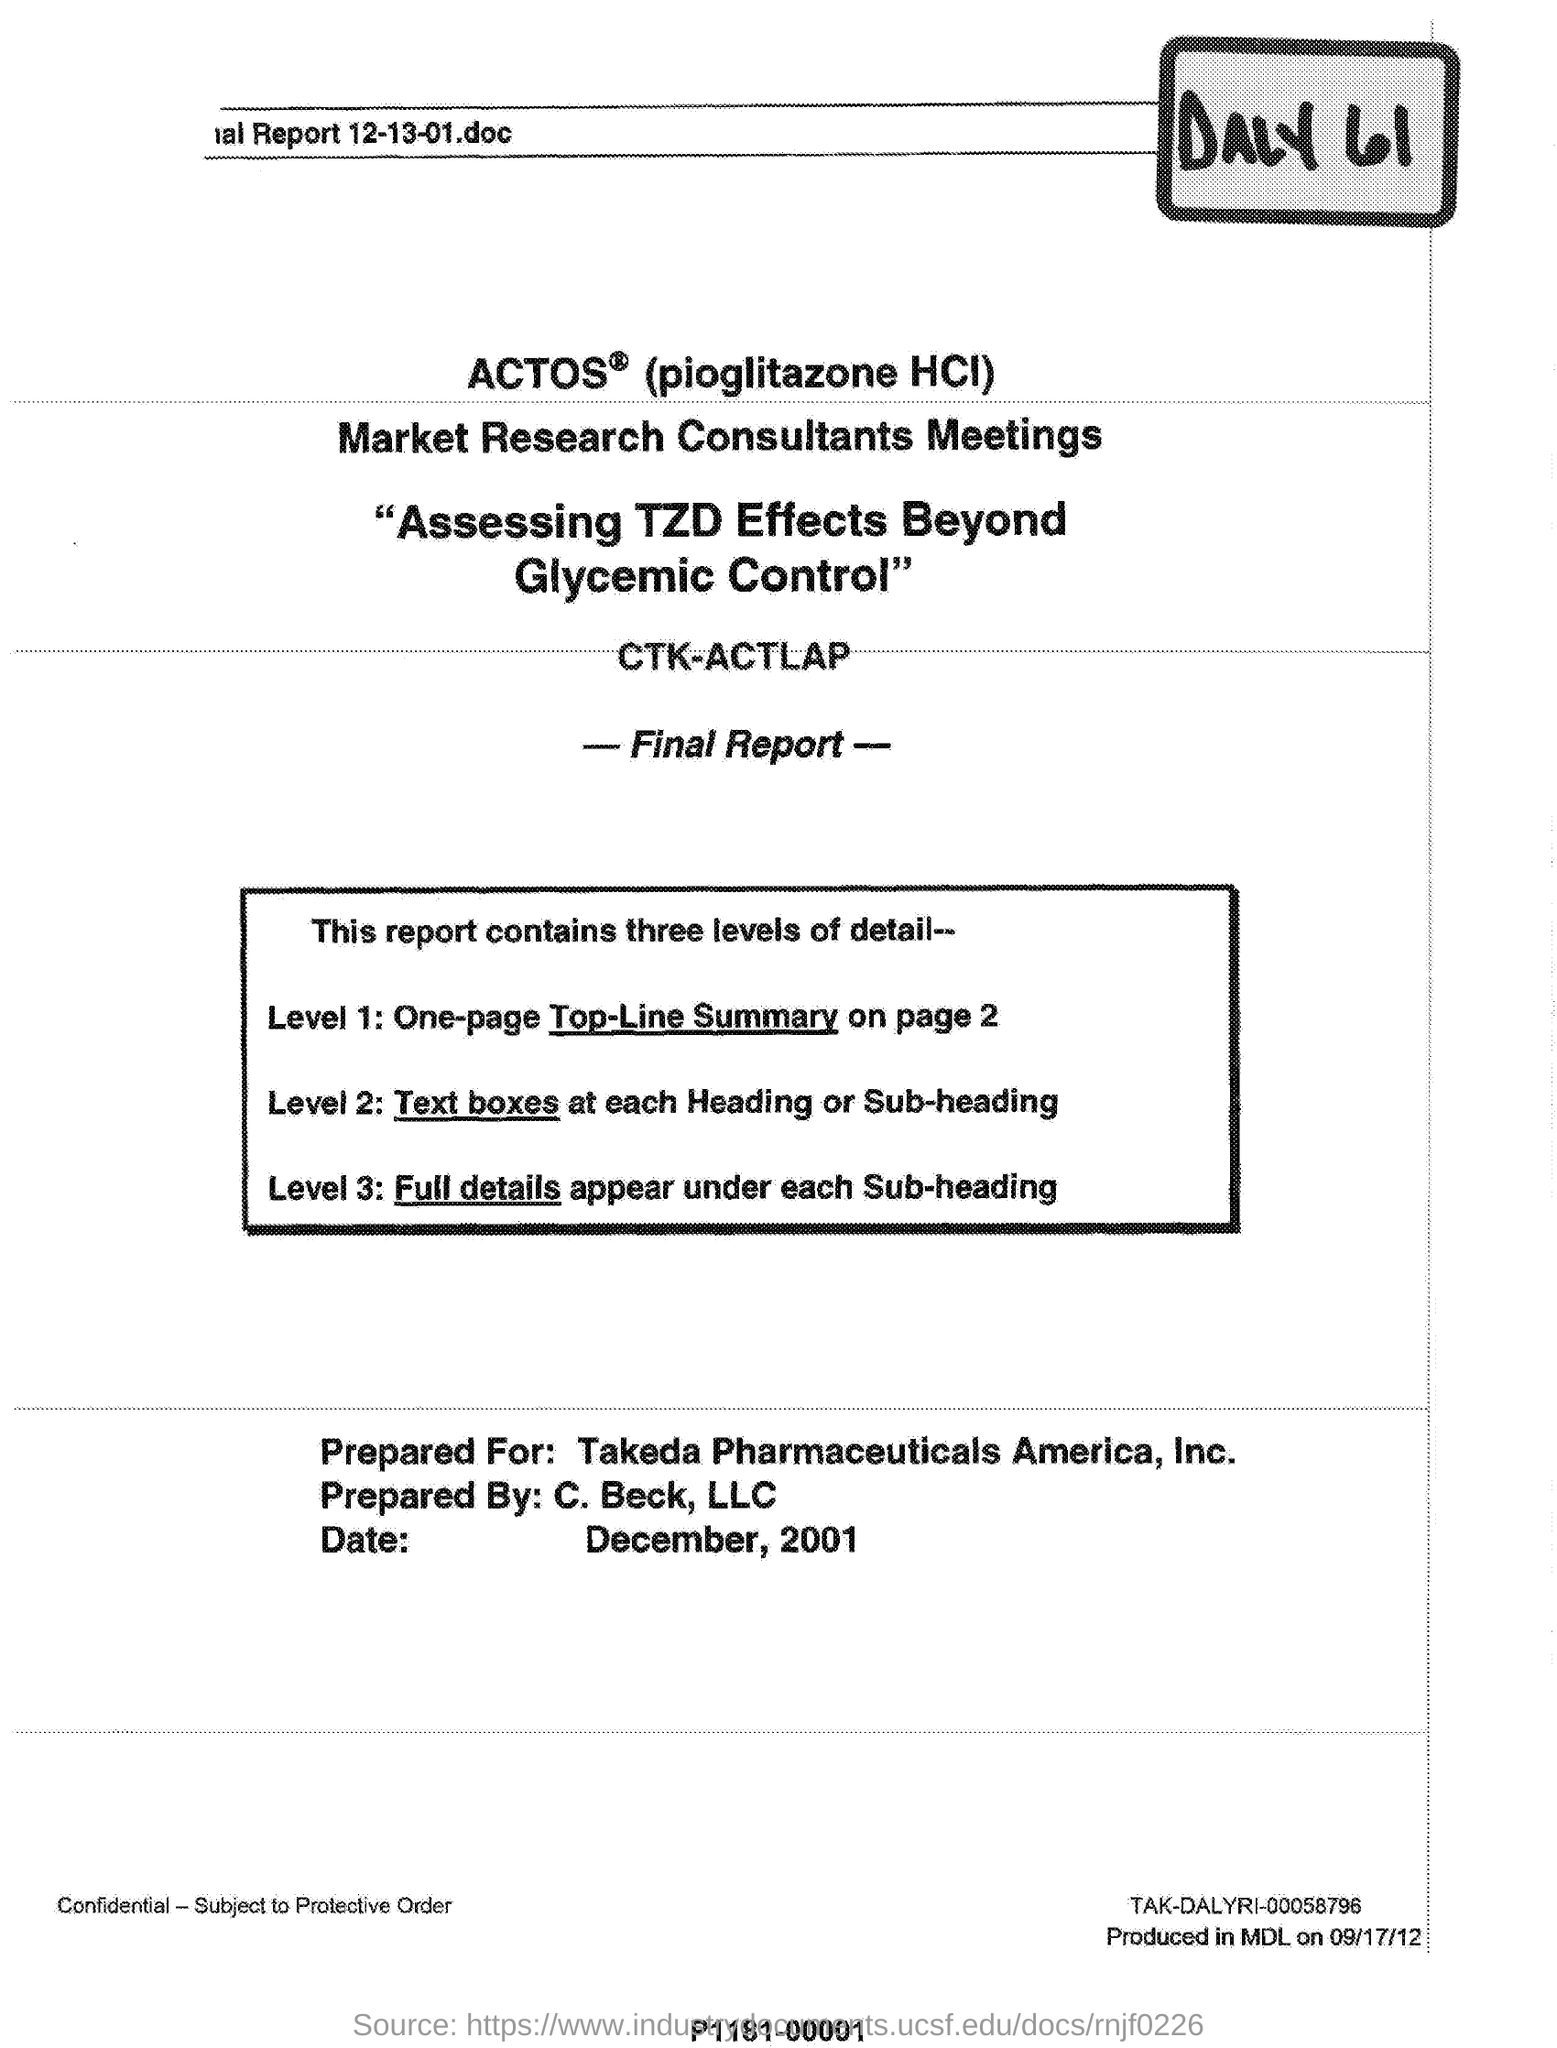Give some essential details in this illustration. The document was prepared by C. Beck, LLC. The date mentioned is December 2001. 